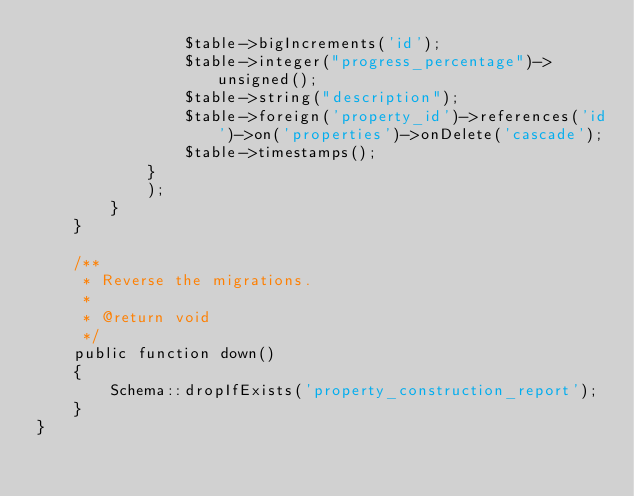Convert code to text. <code><loc_0><loc_0><loc_500><loc_500><_PHP_>                $table->bigIncrements('id');
                $table->integer("progress_percentage")->unsigned();
                $table->string("description");
                $table->foreign('property_id')->references('id')->on('properties')->onDelete('cascade');
                $table->timestamps();
            }
            );
        }
    }

    /**
     * Reverse the migrations.
     *
     * @return void
     */
    public function down()
    {
        Schema::dropIfExists('property_construction_report');
    }
}
</code> 